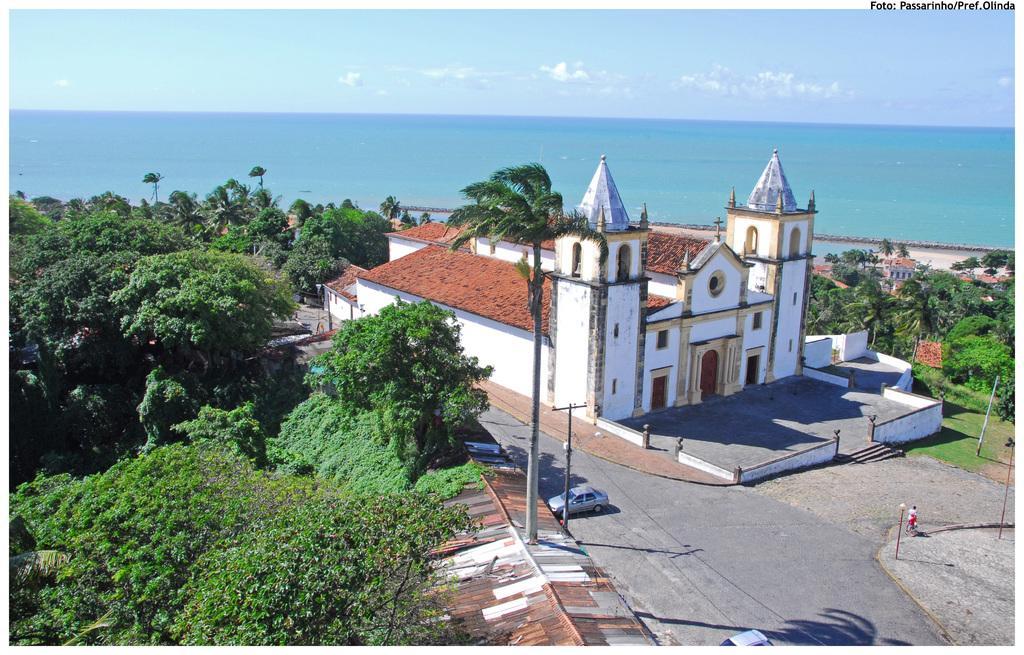In one or two sentences, can you explain what this image depicts? In this image I can see the road. There is a vehicle on the road. I can also see many poles and buildings to the side of the road. To the right I can see the person. I can also see many trees around the building. In the background I can see the water clouds and the sky. 